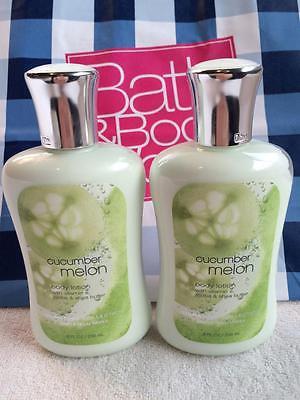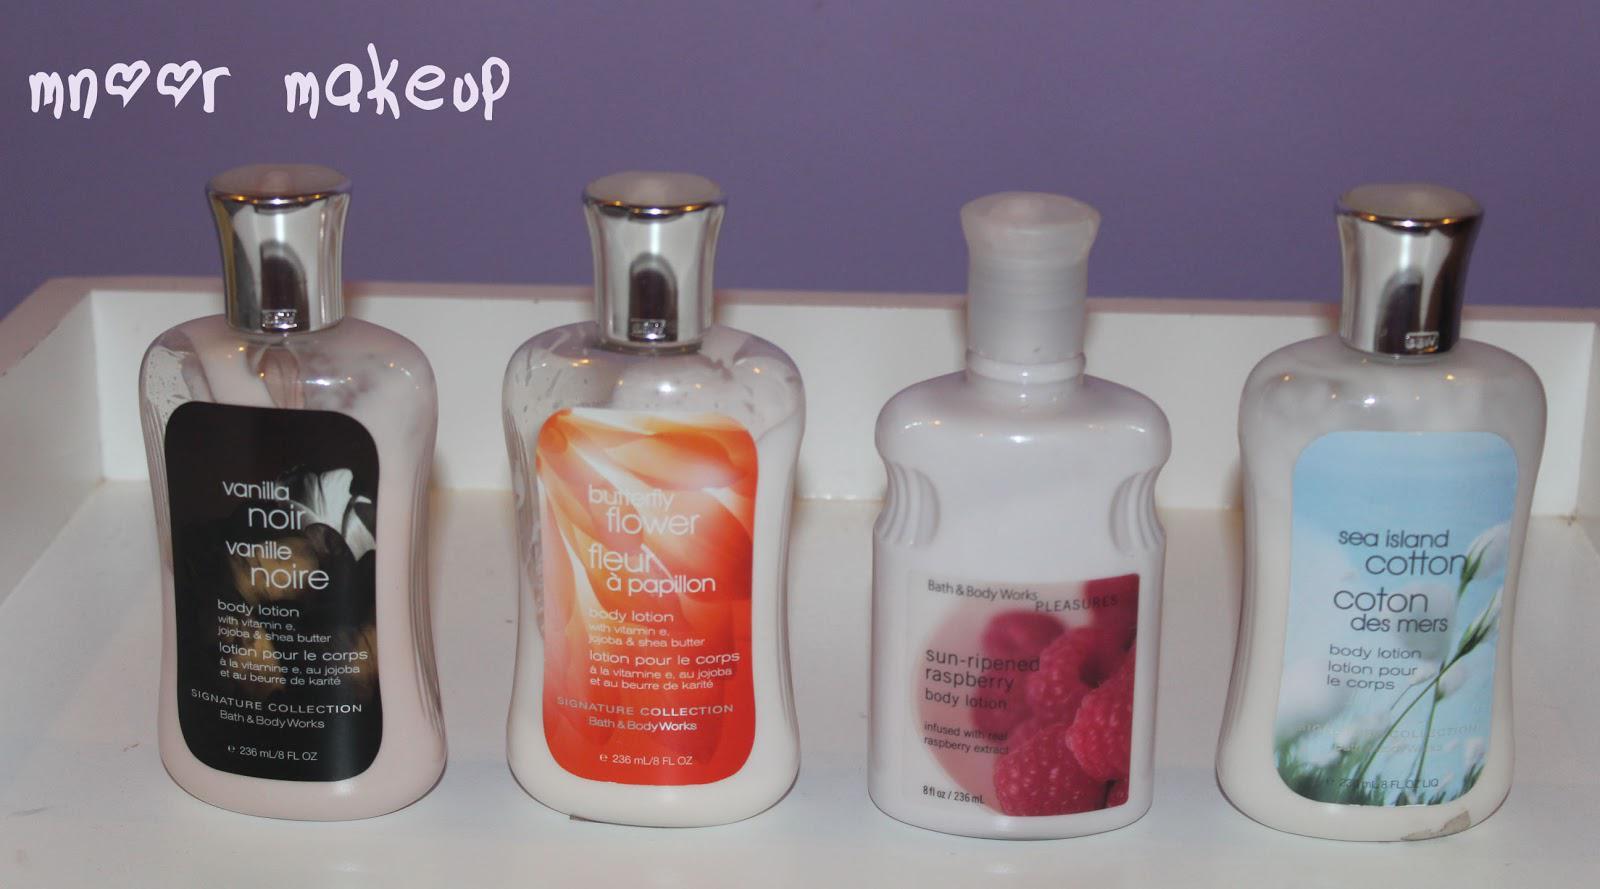The first image is the image on the left, the second image is the image on the right. Considering the images on both sides, is "There are more than seven bath products." valid? Answer yes or no. No. The first image is the image on the left, the second image is the image on the right. Analyze the images presented: Is the assertion "An image contains at least one horizontal row of five skincare products of the same size and shape." valid? Answer yes or no. No. 